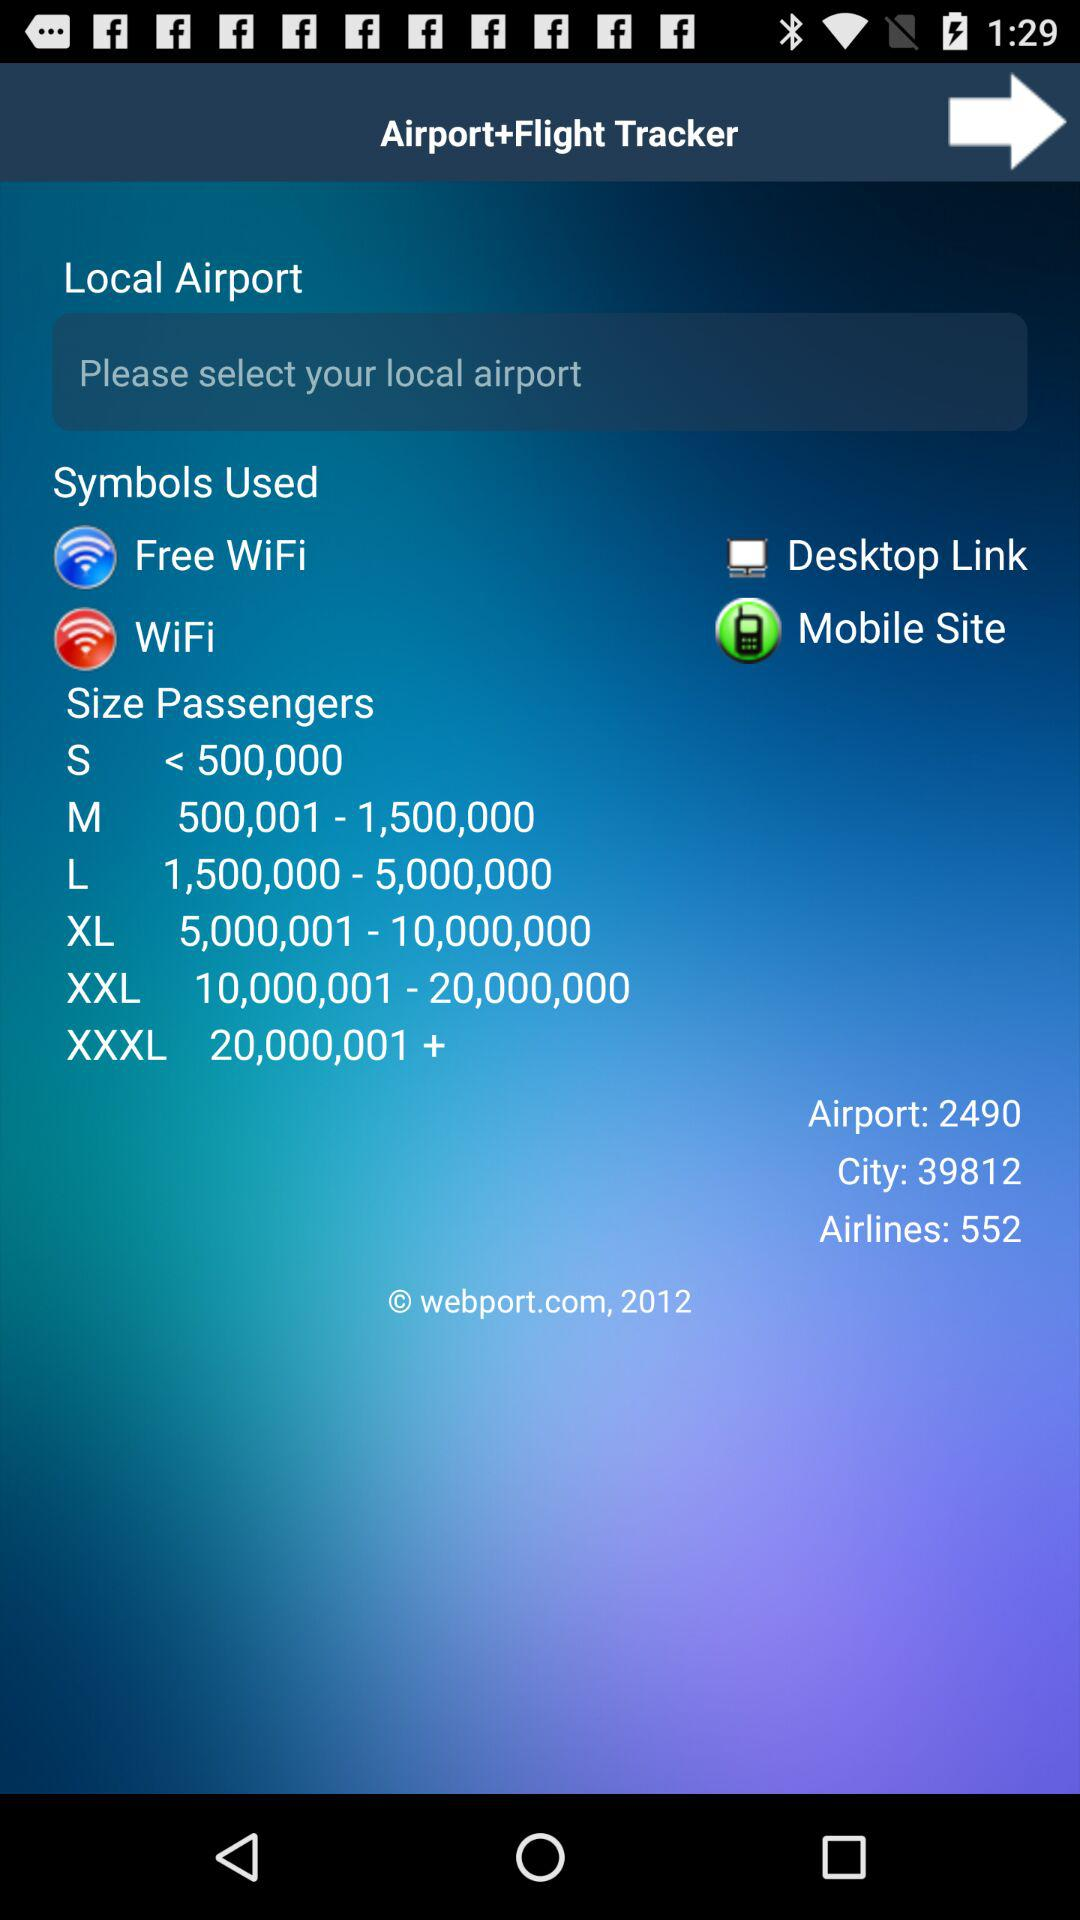What is the total number of airlines? The total number of airlines is 552. 